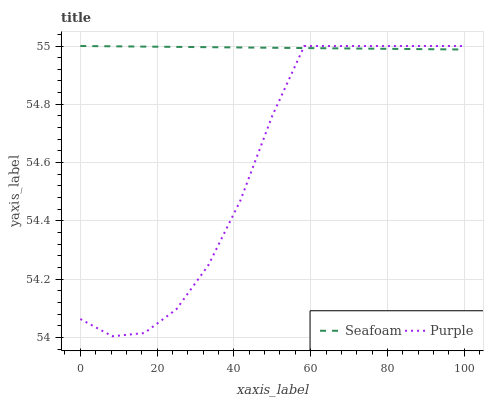Does Purple have the minimum area under the curve?
Answer yes or no. Yes. Does Seafoam have the maximum area under the curve?
Answer yes or no. Yes. Does Seafoam have the minimum area under the curve?
Answer yes or no. No. Is Seafoam the smoothest?
Answer yes or no. Yes. Is Purple the roughest?
Answer yes or no. Yes. Is Seafoam the roughest?
Answer yes or no. No. Does Purple have the lowest value?
Answer yes or no. Yes. Does Seafoam have the lowest value?
Answer yes or no. No. Does Seafoam have the highest value?
Answer yes or no. Yes. Does Purple intersect Seafoam?
Answer yes or no. Yes. Is Purple less than Seafoam?
Answer yes or no. No. Is Purple greater than Seafoam?
Answer yes or no. No. 